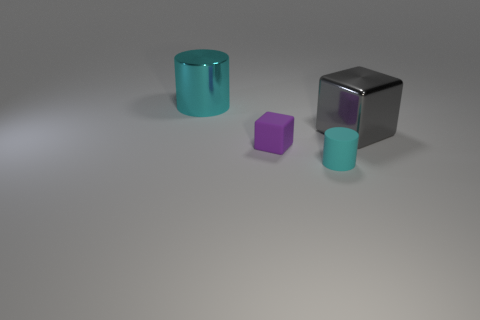Add 3 brown rubber cylinders. How many objects exist? 7 Add 2 metallic spheres. How many metallic spheres exist? 2 Subtract 0 brown cylinders. How many objects are left? 4 Subtract all green things. Subtract all large metal cubes. How many objects are left? 3 Add 1 purple cubes. How many purple cubes are left? 2 